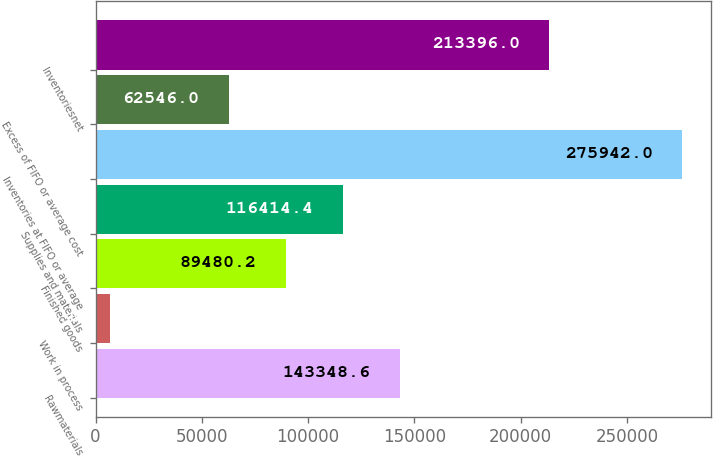Convert chart to OTSL. <chart><loc_0><loc_0><loc_500><loc_500><bar_chart><fcel>Rawmaterials<fcel>Work in process<fcel>Finished goods<fcel>Supplies and materials<fcel>Inventories at FIFO or average<fcel>Excess of FIFO or average cost<fcel>Inventoriesnet<nl><fcel>143349<fcel>6600<fcel>89480.2<fcel>116414<fcel>275942<fcel>62546<fcel>213396<nl></chart> 